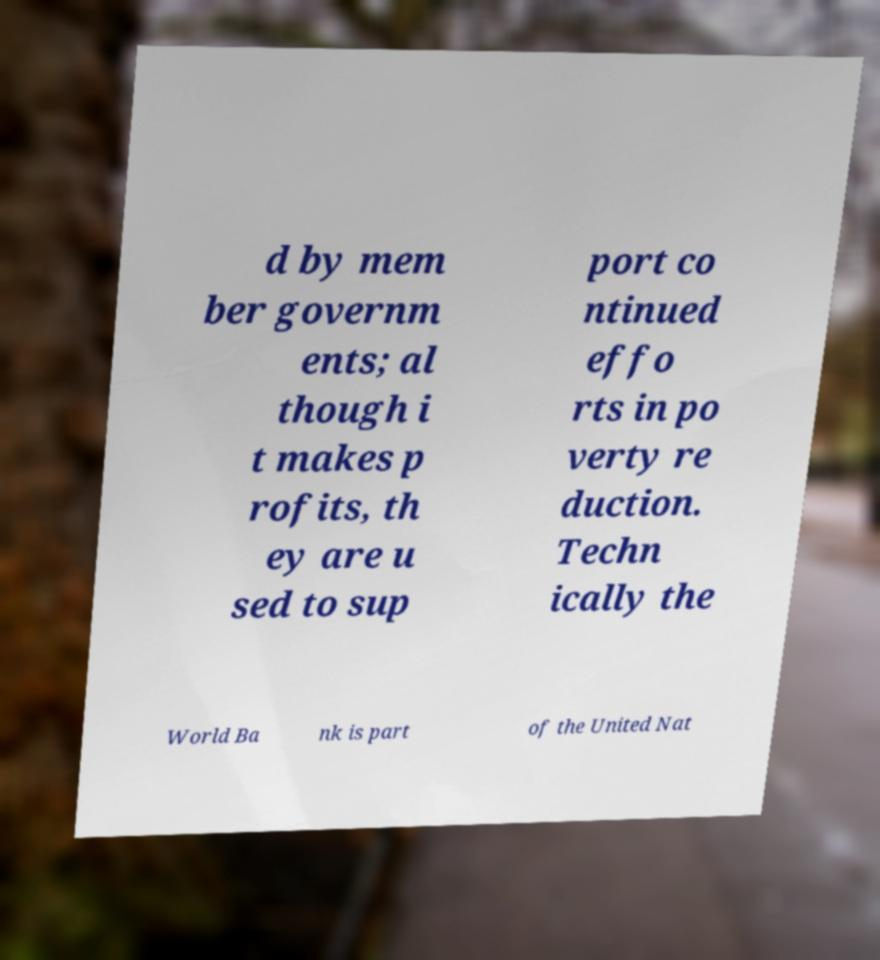I need the written content from this picture converted into text. Can you do that? d by mem ber governm ents; al though i t makes p rofits, th ey are u sed to sup port co ntinued effo rts in po verty re duction. Techn ically the World Ba nk is part of the United Nat 